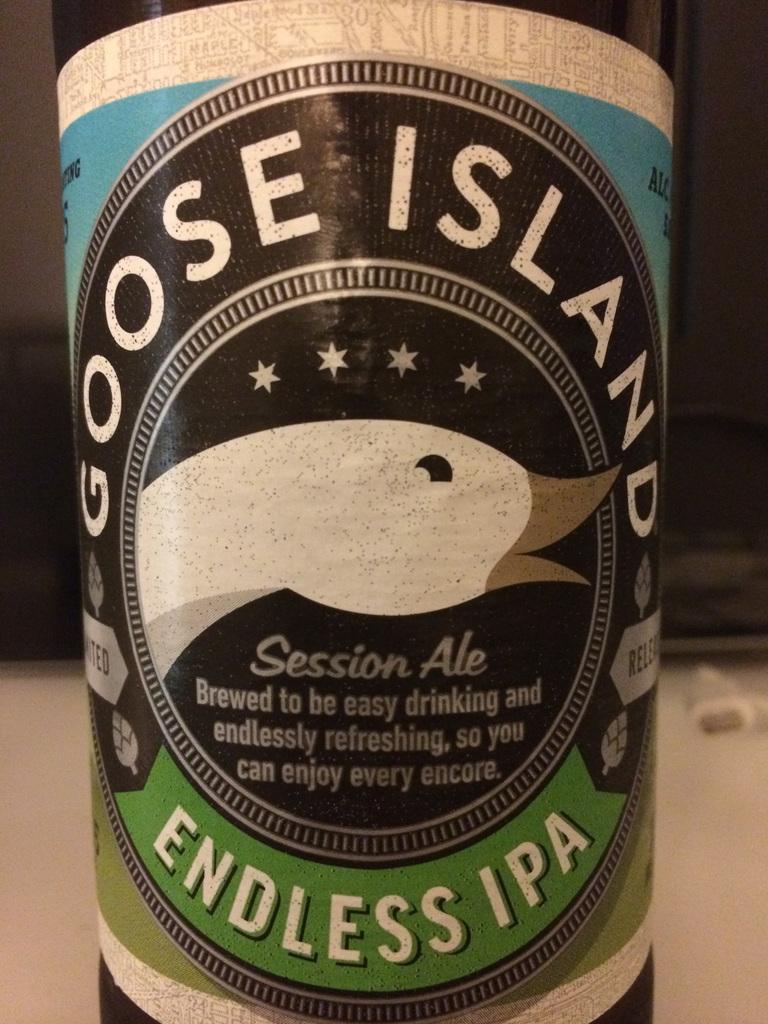What type of beer is this?
Provide a short and direct response. Endless ipa. What is the brand of beer?
Make the answer very short. Goose island. 